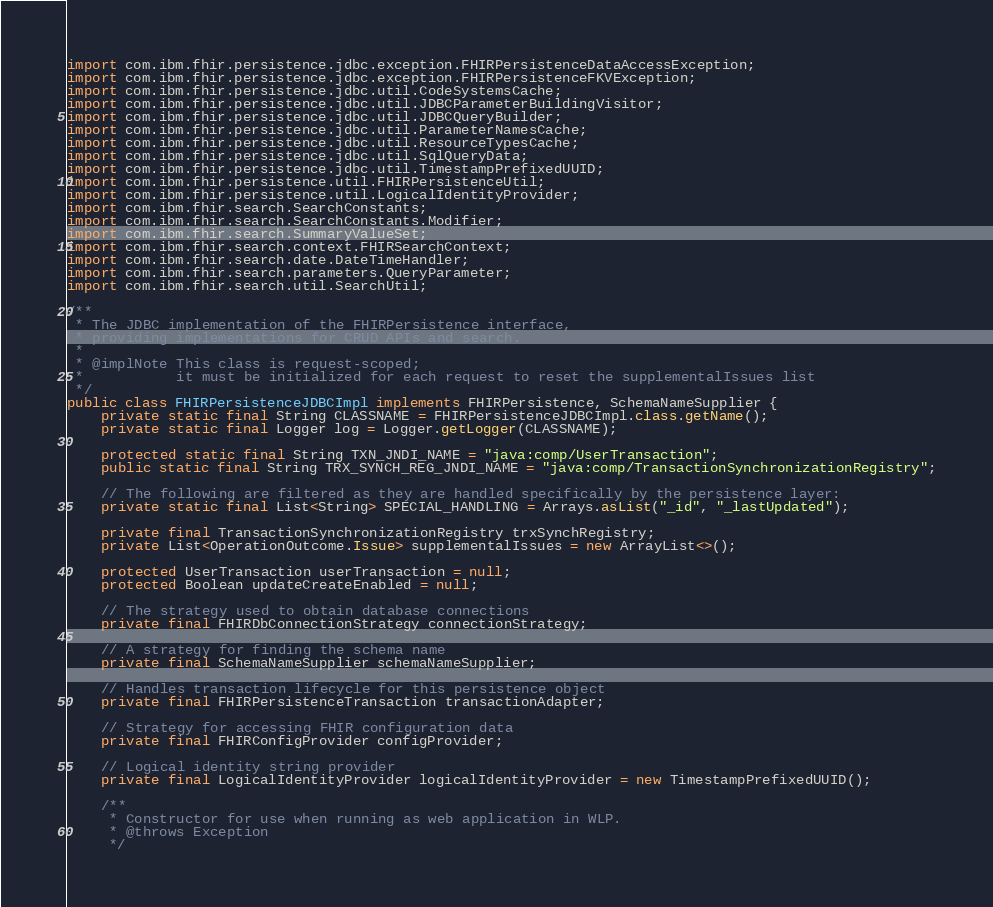Convert code to text. <code><loc_0><loc_0><loc_500><loc_500><_Java_>import com.ibm.fhir.persistence.jdbc.exception.FHIRPersistenceDataAccessException;
import com.ibm.fhir.persistence.jdbc.exception.FHIRPersistenceFKVException;
import com.ibm.fhir.persistence.jdbc.util.CodeSystemsCache;
import com.ibm.fhir.persistence.jdbc.util.JDBCParameterBuildingVisitor;
import com.ibm.fhir.persistence.jdbc.util.JDBCQueryBuilder;
import com.ibm.fhir.persistence.jdbc.util.ParameterNamesCache;
import com.ibm.fhir.persistence.jdbc.util.ResourceTypesCache;
import com.ibm.fhir.persistence.jdbc.util.SqlQueryData;
import com.ibm.fhir.persistence.jdbc.util.TimestampPrefixedUUID;
import com.ibm.fhir.persistence.util.FHIRPersistenceUtil;
import com.ibm.fhir.persistence.util.LogicalIdentityProvider;
import com.ibm.fhir.search.SearchConstants;
import com.ibm.fhir.search.SearchConstants.Modifier;
import com.ibm.fhir.search.SummaryValueSet;
import com.ibm.fhir.search.context.FHIRSearchContext;
import com.ibm.fhir.search.date.DateTimeHandler;
import com.ibm.fhir.search.parameters.QueryParameter;
import com.ibm.fhir.search.util.SearchUtil;

/**
 * The JDBC implementation of the FHIRPersistence interface,
 * providing implementations for CRUD APIs and search.
 *
 * @implNote This class is request-scoped;
 *           it must be initialized for each request to reset the supplementalIssues list
 */
public class FHIRPersistenceJDBCImpl implements FHIRPersistence, SchemaNameSupplier {
    private static final String CLASSNAME = FHIRPersistenceJDBCImpl.class.getName();
    private static final Logger log = Logger.getLogger(CLASSNAME);

    protected static final String TXN_JNDI_NAME = "java:comp/UserTransaction";
    public static final String TRX_SYNCH_REG_JNDI_NAME = "java:comp/TransactionSynchronizationRegistry";

    // The following are filtered as they are handled specifically by the persistence layer:
    private static final List<String> SPECIAL_HANDLING = Arrays.asList("_id", "_lastUpdated");

    private final TransactionSynchronizationRegistry trxSynchRegistry;
    private List<OperationOutcome.Issue> supplementalIssues = new ArrayList<>();

    protected UserTransaction userTransaction = null;
    protected Boolean updateCreateEnabled = null;

    // The strategy used to obtain database connections
    private final FHIRDbConnectionStrategy connectionStrategy;

    // A strategy for finding the schema name
    private final SchemaNameSupplier schemaNameSupplier;

    // Handles transaction lifecycle for this persistence object
    private final FHIRPersistenceTransaction transactionAdapter;

    // Strategy for accessing FHIR configuration data
    private final FHIRConfigProvider configProvider;

    // Logical identity string provider
    private final LogicalIdentityProvider logicalIdentityProvider = new TimestampPrefixedUUID();

    /**
     * Constructor for use when running as web application in WLP.
     * @throws Exception
     */</code> 